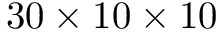Convert formula to latex. <formula><loc_0><loc_0><loc_500><loc_500>3 0 \times 1 0 \times 1 0</formula> 